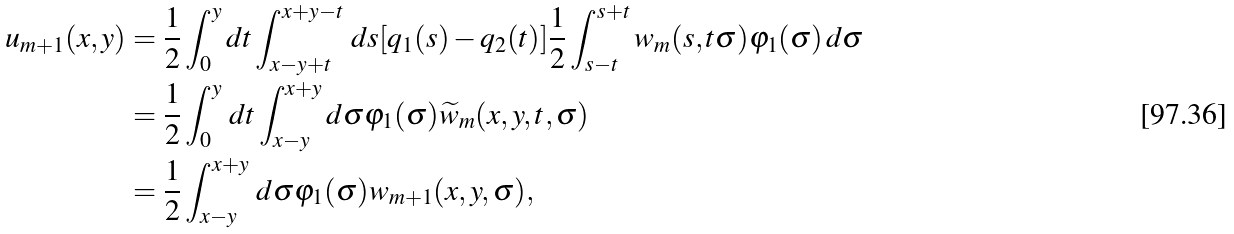<formula> <loc_0><loc_0><loc_500><loc_500>u _ { m + 1 } ( x , y ) & = \frac { 1 } { 2 } \int ^ { y } _ { 0 } d t \int ^ { x + y - t } _ { x - y + t } \, d s [ q _ { 1 } ( s ) - q _ { 2 } ( t ) ] \frac { 1 } { 2 } \int ^ { s + t } _ { s - t } w _ { m } ( s , t \sigma ) \varphi _ { 1 } ( \sigma ) \, d \sigma \\ & = \frac { 1 } { 2 } \int ^ { y } _ { 0 } \, d t \int ^ { x + y } _ { x - y } d \sigma \varphi _ { 1 } ( \sigma ) \widetilde { w } _ { m } ( x , y , t , \sigma ) \\ & = \frac { 1 } { 2 } \int ^ { x + y } _ { x - y } \, d \sigma \varphi _ { 1 } ( \sigma ) w _ { m + 1 } ( x , y , \sigma ) ,</formula> 